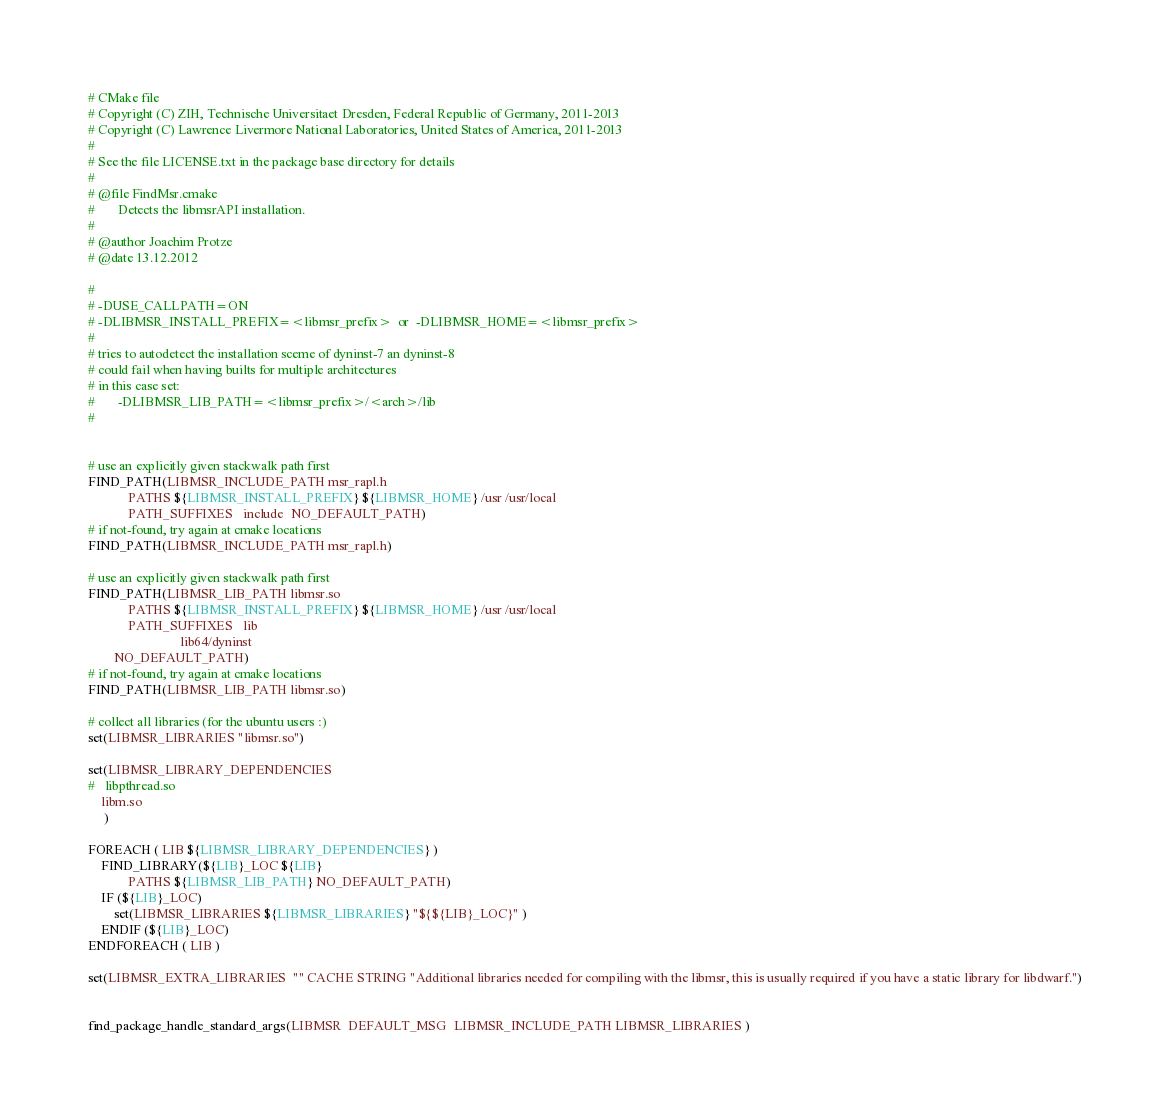<code> <loc_0><loc_0><loc_500><loc_500><_CMake_># CMake file
# Copyright (C) ZIH, Technische Universitaet Dresden, Federal Republic of Germany, 2011-2013
# Copyright (C) Lawrence Livermore National Laboratories, United States of America, 2011-2013
#
# See the file LICENSE.txt in the package base directory for details
#
# @file FindMsr.cmake
#       Detects the libmsrAPI installation.
#
# @author Joachim Protze
# @date 13.12.2012

#
# -DUSE_CALLPATH=ON
# -DLIBMSR_INSTALL_PREFIX=<libmsr_prefix>  or  -DLIBMSR_HOME=<libmsr_prefix>
#
# tries to autodetect the installation sceme of dyninst-7 an dyninst-8
# could fail when having builts for multiple architectures
# in this case set:
#       -DLIBMSR_LIB_PATH=<libmsr_prefix>/<arch>/lib
#


# use an explicitly given stackwalk path first
FIND_PATH(LIBMSR_INCLUDE_PATH msr_rapl.h 
            PATHS ${LIBMSR_INSTALL_PREFIX} ${LIBMSR_HOME} /usr /usr/local
            PATH_SUFFIXES   include  NO_DEFAULT_PATH)
# if not-found, try again at cmake locations
FIND_PATH(LIBMSR_INCLUDE_PATH msr_rapl.h)

# use an explicitly given stackwalk path first
FIND_PATH(LIBMSR_LIB_PATH libmsr.so 
            PATHS ${LIBMSR_INSTALL_PREFIX} ${LIBMSR_HOME} /usr /usr/local
            PATH_SUFFIXES   lib 
                            lib64/dyninst
		NO_DEFAULT_PATH)
# if not-found, try again at cmake locations
FIND_PATH(LIBMSR_LIB_PATH libmsr.so)

# collect all libraries (for the ubuntu users :)
set(LIBMSR_LIBRARIES "libmsr.so")

set(LIBMSR_LIBRARY_DEPENDENCIES
#	libpthread.so
	libm.so
     )

FOREACH ( LIB ${LIBMSR_LIBRARY_DEPENDENCIES} )
    FIND_LIBRARY(${LIB}_LOC ${LIB} 
            PATHS ${LIBMSR_LIB_PATH} NO_DEFAULT_PATH)
    IF (${LIB}_LOC)
        set(LIBMSR_LIBRARIES ${LIBMSR_LIBRARIES} "${${LIB}_LOC}" )
    ENDIF (${LIB}_LOC)
ENDFOREACH ( LIB )

set(LIBMSR_EXTRA_LIBRARIES  "" CACHE STRING "Additional libraries needed for compiling with the libmsr, this is usually required if you have a static library for libdwarf.")


find_package_handle_standard_args(LIBMSR  DEFAULT_MSG  LIBMSR_INCLUDE_PATH LIBMSR_LIBRARIES )

</code> 